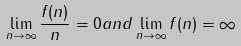<formula> <loc_0><loc_0><loc_500><loc_500>\lim _ { n \rightarrow \infty } \frac { f ( n ) } { n } = 0 a n d \lim _ { n \rightarrow \infty } f ( n ) = \infty</formula> 